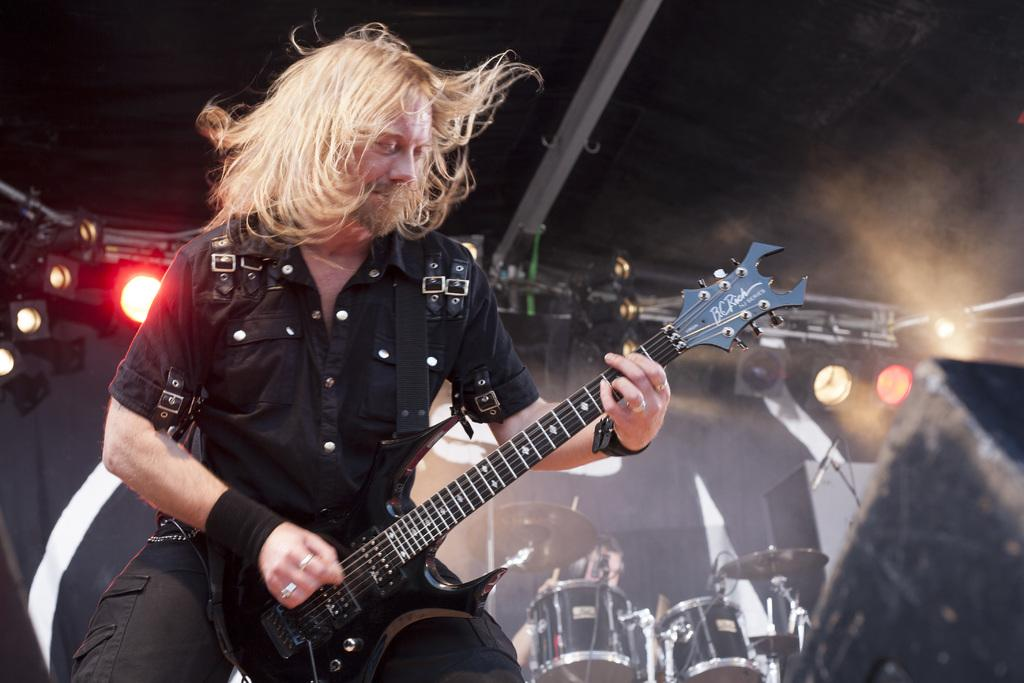What is the man in the image doing? The man is playing a guitar. What is the man wearing in the image? The man is wearing a black shirt and trousers. What can be seen in the background of the image? There are drums, a person, lights, and a speaker in the background of the image. What type of skirt is the person wearing in the image? There is no skirt present in the image; the person in the background is not visible in enough detail to determine their clothing. 